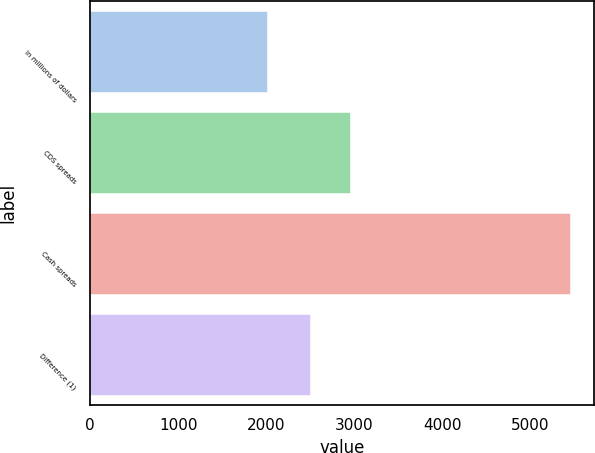Convert chart to OTSL. <chart><loc_0><loc_0><loc_500><loc_500><bar_chart><fcel>In millions of dollars<fcel>CDS spreads<fcel>Cash spreads<fcel>Difference (1)<nl><fcel>2008<fcel>2953<fcel>5446<fcel>2493<nl></chart> 